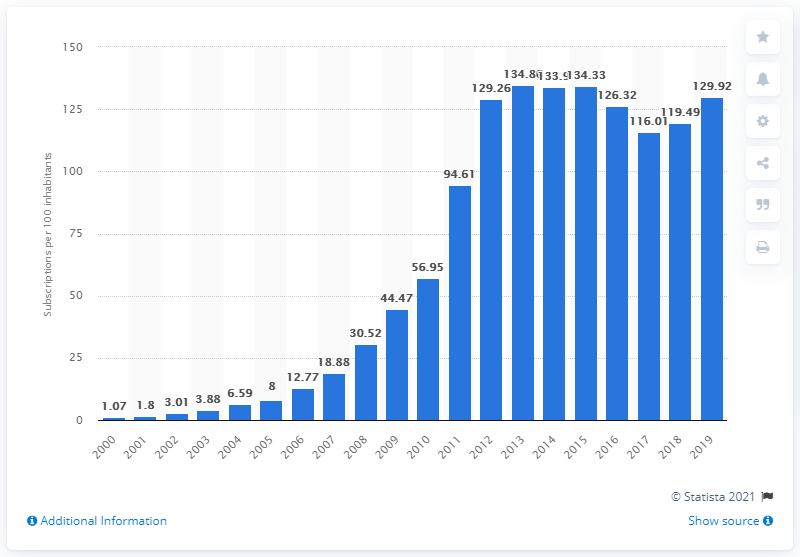Point out several critical features in this image. The number of mobile subscriptions for every 100 people in Cambodia increased from 129.92 in 2000 to 130.14 in 2019. 